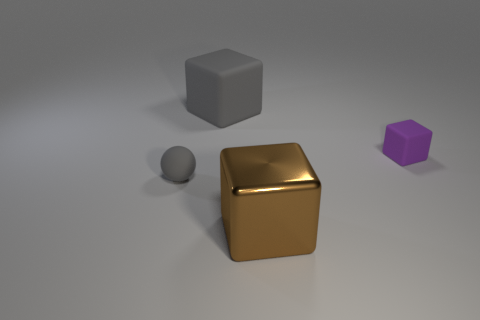Subtract all cyan spheres. Subtract all red cubes. How many spheres are left? 1 Add 2 brown shiny objects. How many objects exist? 6 Subtract all cubes. How many objects are left? 1 Add 1 gray spheres. How many gray spheres exist? 2 Subtract 0 purple cylinders. How many objects are left? 4 Subtract all small purple cubes. Subtract all purple blocks. How many objects are left? 2 Add 4 large rubber cubes. How many large rubber cubes are left? 5 